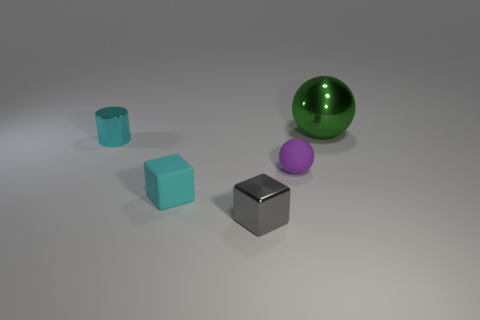What color is the cylinder that is the same size as the rubber sphere?
Offer a terse response. Cyan. What shape is the tiny cyan thing that is left of the matte object in front of the tiny purple ball?
Make the answer very short. Cylinder. There is a metal thing left of the gray block; does it have the same size as the cyan matte block?
Your answer should be compact. Yes. How many other objects are there of the same material as the big object?
Your answer should be very brief. 2. What number of green objects are either shiny cylinders or big things?
Provide a succinct answer. 1. There is a small purple thing; how many big green things are behind it?
Ensure brevity in your answer.  1. What is the size of the thing to the right of the rubber thing to the right of the tiny thing in front of the cyan rubber cube?
Give a very brief answer. Large. Are there any small balls in front of the metal object behind the cyan object that is behind the small purple object?
Provide a short and direct response. Yes. Is the number of tiny rubber spheres greater than the number of blue rubber balls?
Provide a short and direct response. Yes. There is a sphere that is in front of the metal cylinder; what is its color?
Your answer should be compact. Purple. 